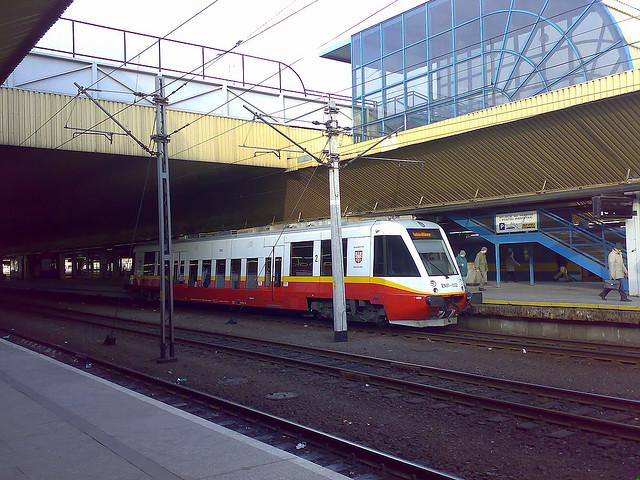What are the wires above the train used for? electricity 